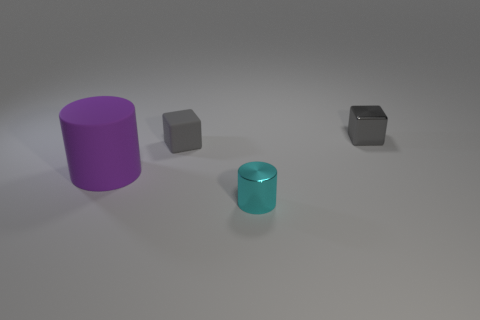Add 4 tiny matte objects. How many objects exist? 8 Subtract 1 cubes. How many cubes are left? 1 Subtract all large purple matte objects. Subtract all big cylinders. How many objects are left? 2 Add 4 small objects. How many small objects are left? 7 Add 2 small rubber things. How many small rubber things exist? 3 Subtract 0 red balls. How many objects are left? 4 Subtract all gray cylinders. Subtract all yellow cubes. How many cylinders are left? 2 